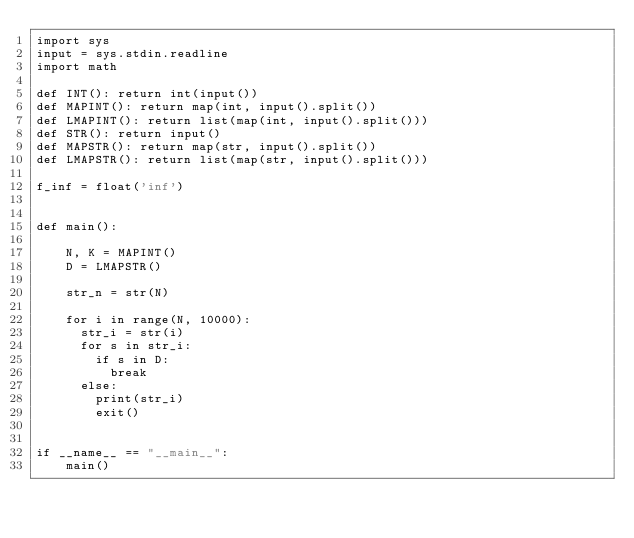Convert code to text. <code><loc_0><loc_0><loc_500><loc_500><_Python_>import sys
input = sys.stdin.readline
import math

def INT(): return int(input())
def MAPINT(): return map(int, input().split())
def LMAPINT(): return list(map(int, input().split()))
def STR(): return input()
def MAPSTR(): return map(str, input().split())
def LMAPSTR(): return list(map(str, input().split()))

f_inf = float('inf')


def main():

    N, K = MAPINT()
    D = LMAPSTR()
    
    str_n = str(N)
    
    for i in range(N, 10000):
      str_i = str(i)
      for s in str_i:
        if s in D:
          break
      else:
        print(str_i)
        exit()

        
if __name__ == "__main__":
    main()
</code> 